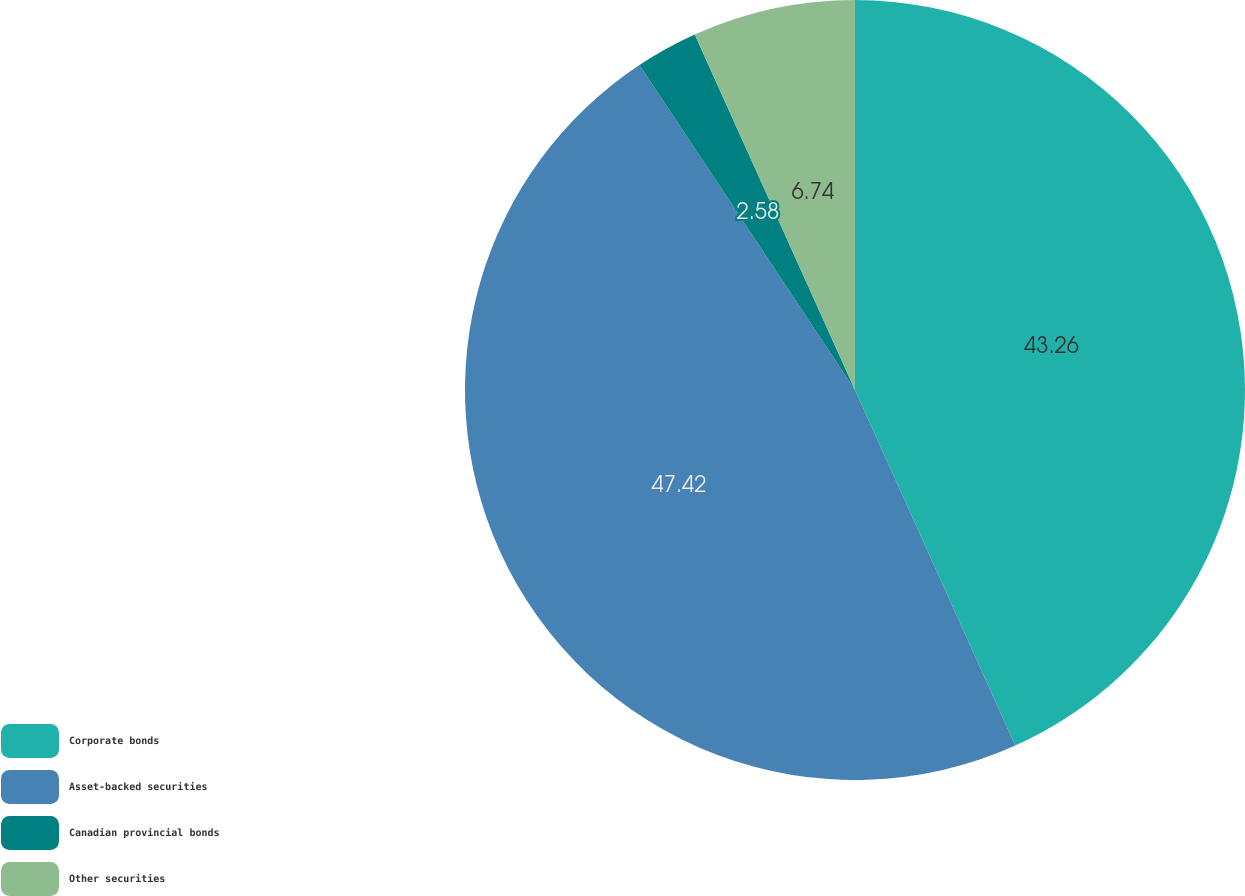Convert chart. <chart><loc_0><loc_0><loc_500><loc_500><pie_chart><fcel>Corporate bonds<fcel>Asset-backed securities<fcel>Canadian provincial bonds<fcel>Other securities<nl><fcel>43.26%<fcel>47.42%<fcel>2.58%<fcel>6.74%<nl></chart> 